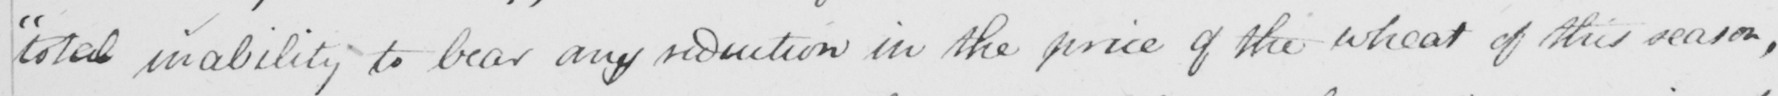Transcribe the text shown in this historical manuscript line. " total inability to bear any reduction in the price of the wheat of this season , 